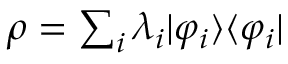Convert formula to latex. <formula><loc_0><loc_0><loc_500><loc_500>\rho = \sum _ { i } \lambda _ { i } | \varphi _ { i } \rangle \langle \varphi _ { i } |</formula> 